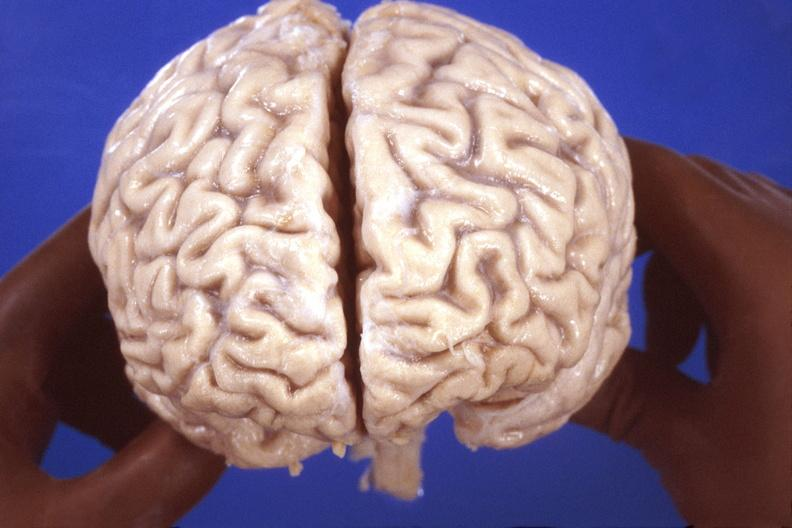s nervous present?
Answer the question using a single word or phrase. Yes 